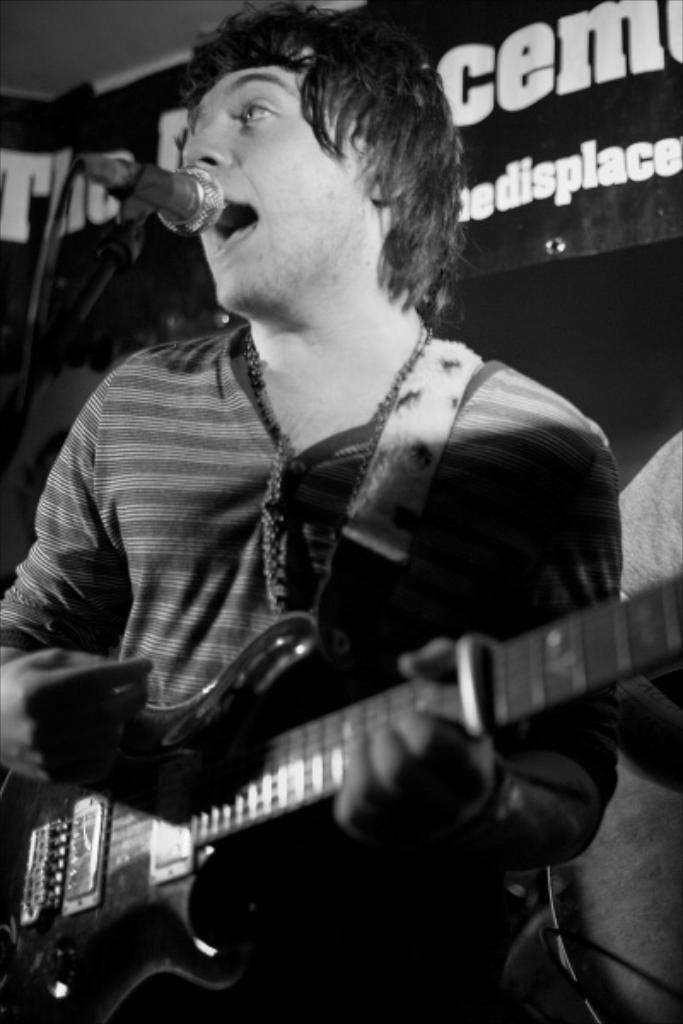What is the man in the image doing? The man is playing the guitar and singing on a microphone. What object is the man holding in the image? The man is holding a guitar in the image. What can be seen in the background of the image? There is a banner in the background of the image. How many icicles are hanging from the man's guitar in the image? There are no icicles present in the image. What type of art is the man creating while playing the guitar? The image does not show the man creating any specific type of art; he is simply playing the guitar and singing. 